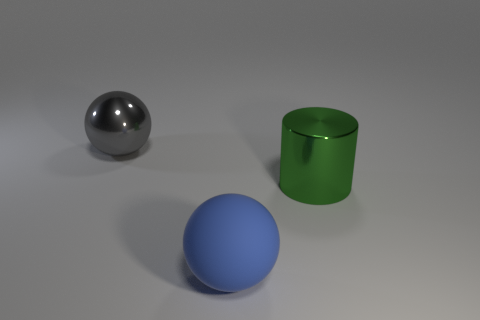Can you describe the shapes and colors of the objects in the image? Certainly! There are three distinct objects. A blue sphere, a silver sphere, and a green cylinder. The spheres are perfectly round, and the cylinder has a circular base with straight sides, lacking a top cover. 